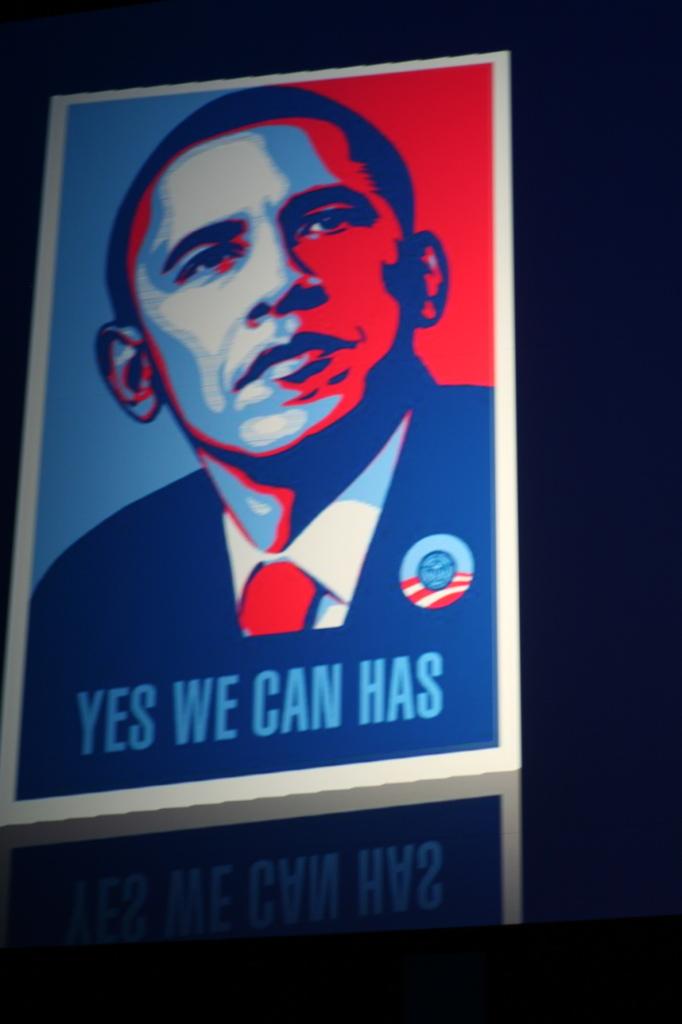Which word on this poster was not originally part of barrack obama's campaign slogan?
Provide a succinct answer. Has. What was the slogan of obama when he first became an candidate?
Ensure brevity in your answer.  Answering does not require reading text in the image. 